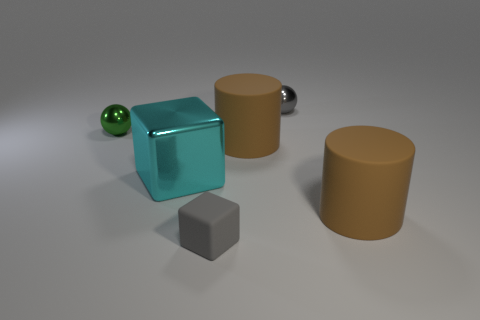There is a sphere that is the same color as the tiny rubber cube; what is its size?
Your response must be concise. Small. Are there any objects of the same color as the matte cube?
Provide a short and direct response. Yes. What shape is the rubber object that is in front of the big brown rubber cylinder that is right of the gray object behind the green metallic thing?
Your response must be concise. Cube. There is a tiny object that is to the right of the small green metallic ball and to the left of the small gray shiny ball; what is its material?
Provide a succinct answer. Rubber. There is a cylinder left of the rubber cylinder to the right of the brown rubber cylinder behind the big cyan object; what color is it?
Offer a terse response. Brown. Is the color of the object to the left of the large cyan metallic cube the same as the rubber cube?
Ensure brevity in your answer.  No. How many other objects are there of the same color as the small matte block?
Give a very brief answer. 1. What number of objects are either tiny cyan metal objects or large blocks?
Your answer should be compact. 1. How many objects are either large cyan objects or balls on the right side of the green ball?
Give a very brief answer. 2. Does the cyan object have the same material as the gray cube?
Your answer should be compact. No. 